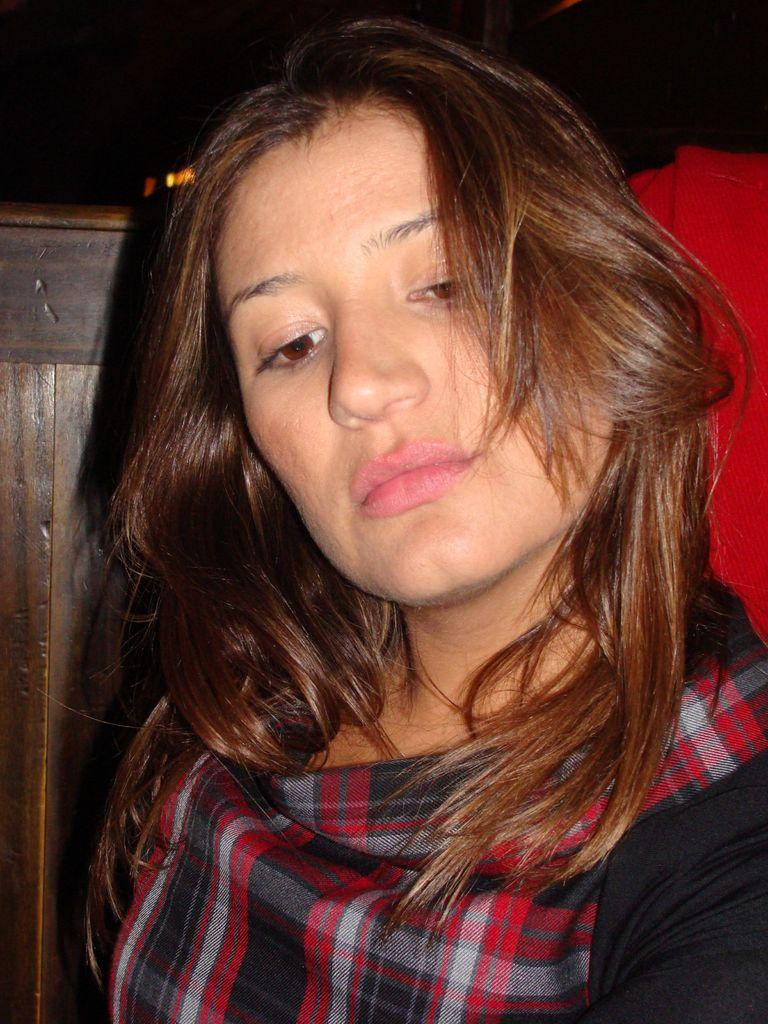Who is present in the image? There is a woman in the image. What is the woman wearing? The woman is wearing a black dress. What type of objects can be seen in the background of the image? There are wooden objects in the background of the image. What color is the object on the right side of the image? There is a red color object on the right side of the image. What type of stew is being prepared in the wilderness in the image? There is no indication of any stew or wilderness in the image; it features a woman wearing a black dress and wooden objects in the background. 